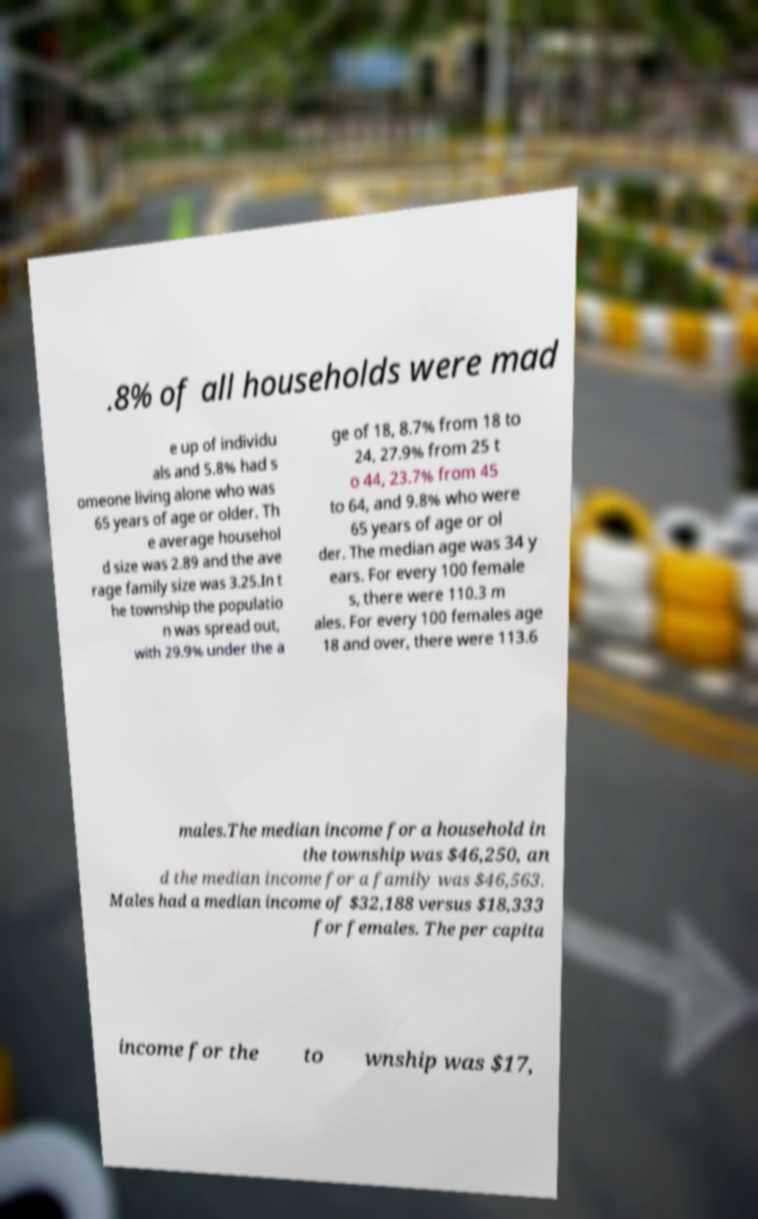There's text embedded in this image that I need extracted. Can you transcribe it verbatim? .8% of all households were mad e up of individu als and 5.8% had s omeone living alone who was 65 years of age or older. Th e average househol d size was 2.89 and the ave rage family size was 3.25.In t he township the populatio n was spread out, with 29.9% under the a ge of 18, 8.7% from 18 to 24, 27.9% from 25 t o 44, 23.7% from 45 to 64, and 9.8% who were 65 years of age or ol der. The median age was 34 y ears. For every 100 female s, there were 110.3 m ales. For every 100 females age 18 and over, there were 113.6 males.The median income for a household in the township was $46,250, an d the median income for a family was $46,563. Males had a median income of $32,188 versus $18,333 for females. The per capita income for the to wnship was $17, 